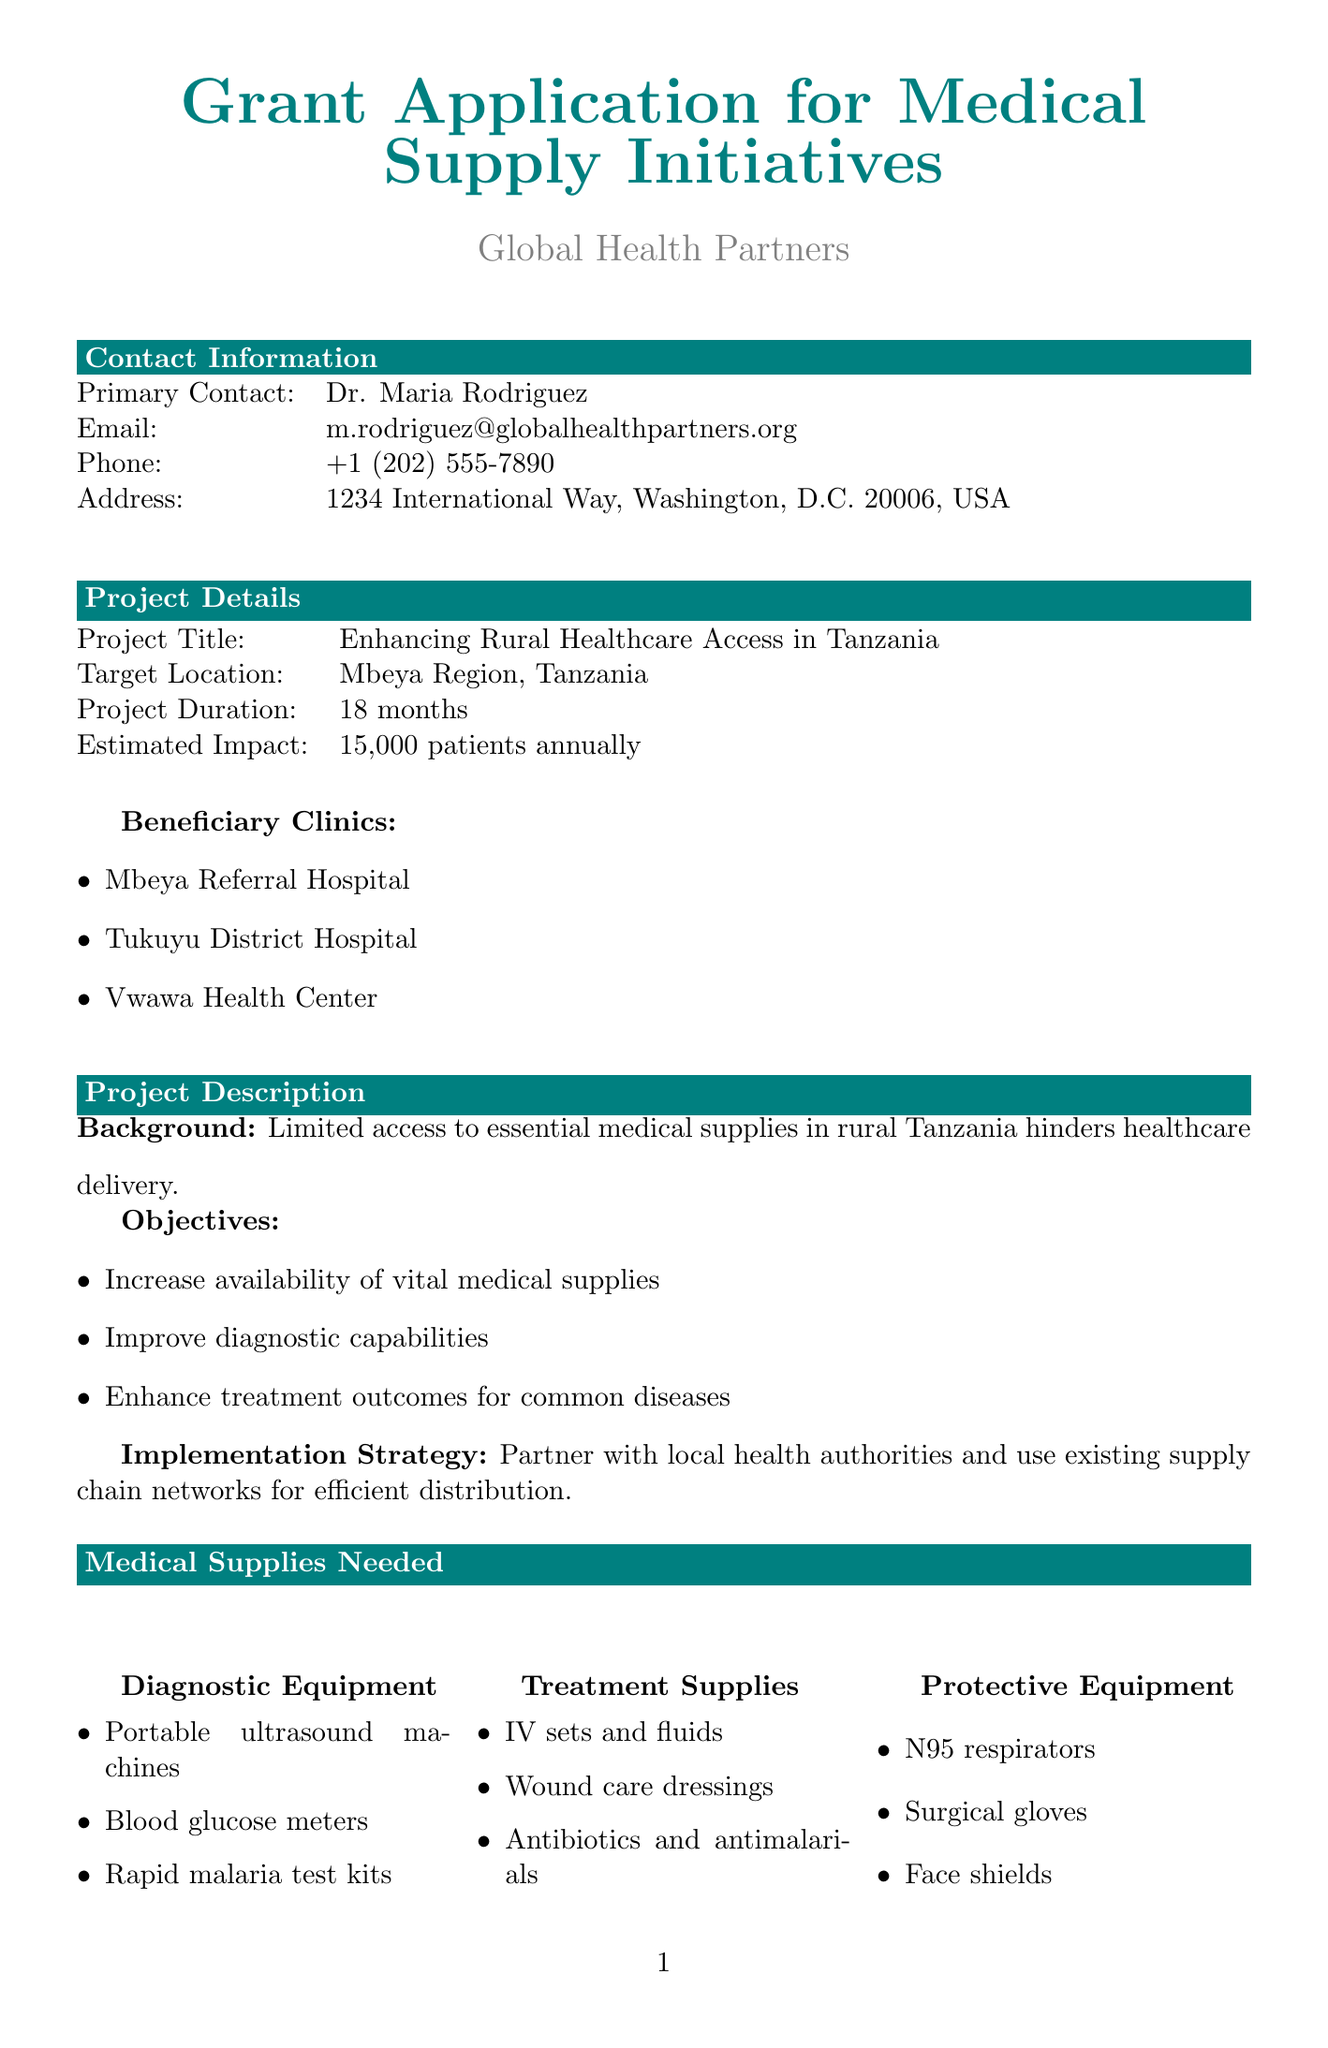what is the project title? The project title is stated in the project details section of the document.
Answer: Enhancing Rural Healthcare Access in Tanzania who is the primary contact? The primary contact is specified in the contact information section of the document.
Answer: Dr. Maria Rodriguez what is the total requested amount? The total requested amount is mentioned in the budget breakdown section of the document.
Answer: $250,000 how many beneficiary clinics are listed? The number of beneficiary clinics is provided in the project details section, which lists specific clinics.
Answer: 3 what percentage of the budget is allocated for medical supplies? The percentage allocated is shown in the budget breakdown section with detailed distribution.
Answer: 72% what is the estimated impact of the project? The estimated impact is detailed in the project details section of the document.
Answer: 15,000 patients annually which local partner is mentioned first? The local partners are listed in the partnerships and sustainability section, and the first one is specified.
Answer: Tanzania Ministry of Health what training amount is allocated in the budget? The allocated amount for training is found in the budget breakdown section.
Answer: $20,000 what are the key indicators for monitoring and evaluation? The key indicators for evaluating the project are listed in the monitoring and evaluation section.
Answer: Number of patients treated with new supplies, Reduction in stock-outs of essential medicines, Improvement in diagnostic accuracy rates 